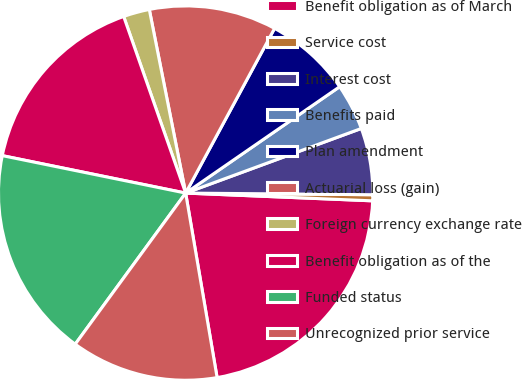<chart> <loc_0><loc_0><loc_500><loc_500><pie_chart><fcel>Benefit obligation as of March<fcel>Service cost<fcel>Interest cost<fcel>Benefits paid<fcel>Plan amendment<fcel>Actuarial loss (gain)<fcel>Foreign currency exchange rate<fcel>Benefit obligation as of the<fcel>Funded status<fcel>Unrecognized prior service<nl><fcel>21.65%<fcel>0.52%<fcel>5.75%<fcel>4.01%<fcel>7.5%<fcel>10.99%<fcel>2.26%<fcel>16.42%<fcel>18.16%<fcel>12.73%<nl></chart> 